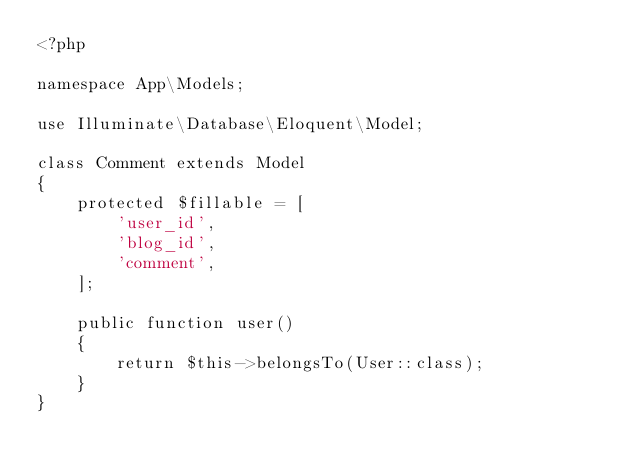<code> <loc_0><loc_0><loc_500><loc_500><_PHP_><?php

namespace App\Models;

use Illuminate\Database\Eloquent\Model;

class Comment extends Model
{
    protected $fillable = [
        'user_id',
        'blog_id',
        'comment',
    ];

    public function user()
    {
        return $this->belongsTo(User::class);
    }
}
</code> 